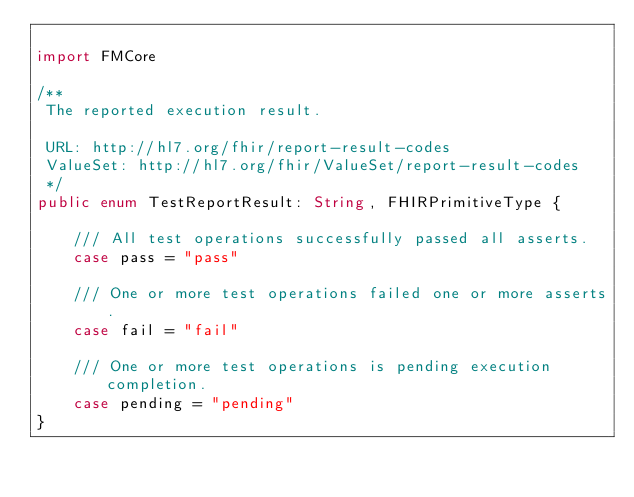<code> <loc_0><loc_0><loc_500><loc_500><_Swift_>
import FMCore

/**
 The reported execution result.
 
 URL: http://hl7.org/fhir/report-result-codes
 ValueSet: http://hl7.org/fhir/ValueSet/report-result-codes
 */
public enum TestReportResult: String, FHIRPrimitiveType {
	
	/// All test operations successfully passed all asserts.
	case pass = "pass"
	
	/// One or more test operations failed one or more asserts.
	case fail = "fail"
	
	/// One or more test operations is pending execution completion.
	case pending = "pending"
}
</code> 